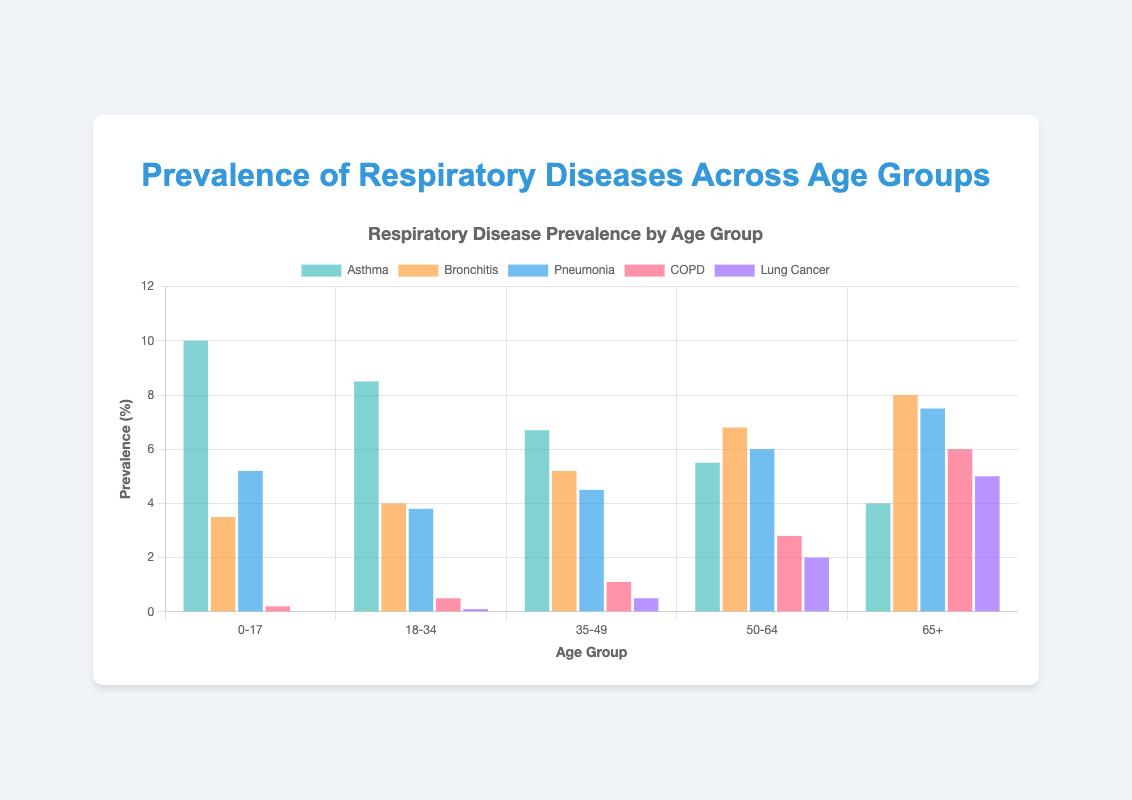What age group has the highest prevalence of COPD? The age group "65+" has a COPD prevalence of 6.0%, which is the highest among all age groups.
Answer: 65+ Which respiratory disease is least prevalent in the "50-64" age group? In the "50-64" age group, the prevalence rates of different respiratory diseases are as follows: Asthma 5.5%, Bronchitis 6.8%, Pneumonia 6.0%, COPD 2.8%, and Lung Cancer 2.0%. The least prevalent disease is COPD at 2.8%.
Answer: COPD What is the total prevalence of respiratory diseases for the "0-17" age group? To calculate the total prevalence, sum the prevalence rates of all diseases for the "0-17" age group: Asthma 10.0%, Bronchitis 3.5%, Pneumonia 5.2%, COPD 0.2%, and Lung Cancer 0.0%. Summing these values: 10.0 + 3.5 + 5.2 + 0.2 + 0.0 = 18.9%.
Answer: 18.9% How does the prevalence of Lung Cancer in the "65+" age group compare to the "35-49" age group? In the "65+" age group, the prevalence of Lung Cancer is 5.0%, while in the "35-49" age group, it is 0.5%. The prevalence in the "65+" age group is higher by 4.5%.
Answer: 5.0% is 4.5% higher What is the average prevalence rate of Bronchitis across all age groups? To find the average prevalence rate of Bronchitis, sum the prevalence rates for all age groups: 3.5%, 4.0%, 5.2%, 6.8%, and 8.0%, then divide by the number of age groups: (3.5 + 4.0 + 5.2 + 6.8 + 8.0) / 5 = 27.5 / 5 = 5.5%.
Answer: 5.5% Which respiratory disease has the most consistent prevalence across all age groups? By examining the prevalence rates for each disease across all age groups, we observe the following variations: Asthma (6.0 range), Bronchitis (4.5 range), Pneumonia (3.7 range), COPD (5.8 range), and Lung Cancer (5.0 range). Pneumonia has the smallest variation, indicating the most consistent prevalence.
Answer: Pneumonia Among the diseases presented, which one shows a significant increase in prevalence with age? By reviewing the data, COPD has a noticeable increase in prevalence with age: 0.2% (0-17), 0.5% (18-34), 1.1% (35-49), 2.8% (50-64), and 6.0% (65+), showing a steady rise across age groups.
Answer: COPD What is the combined prevalence of Asthma and Bronchitis in the "18-34" age group? To find the combined prevalence, sum the prevalence rates of Asthma and Bronchitis in the "18-34" age group: Asthma 8.5% and Bronchitis 4.0%. Thus, 8.5 + 4.0 = 12.5%.
Answer: 12.5% 